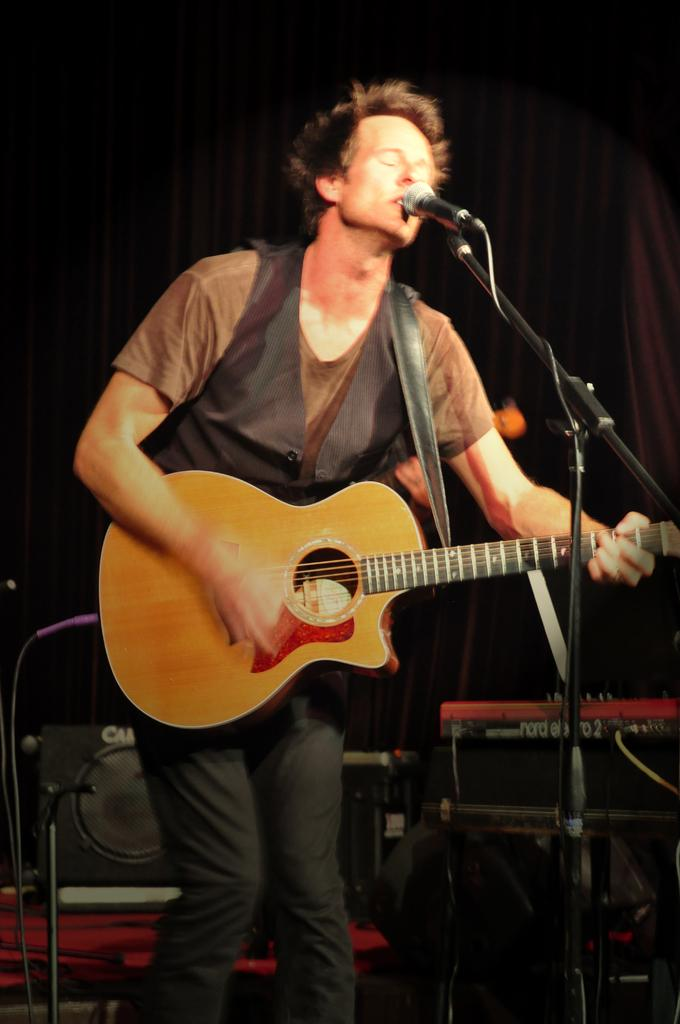Who is the main subject in the image? There is a man in the image. What is the man doing in the image? The man is standing, playing a guitar, singing, and using a microphone. What type of quilt is the man using to play the guitar in the image? There is no quilt present in the image, and the man is not using any quilt to play the guitar. 